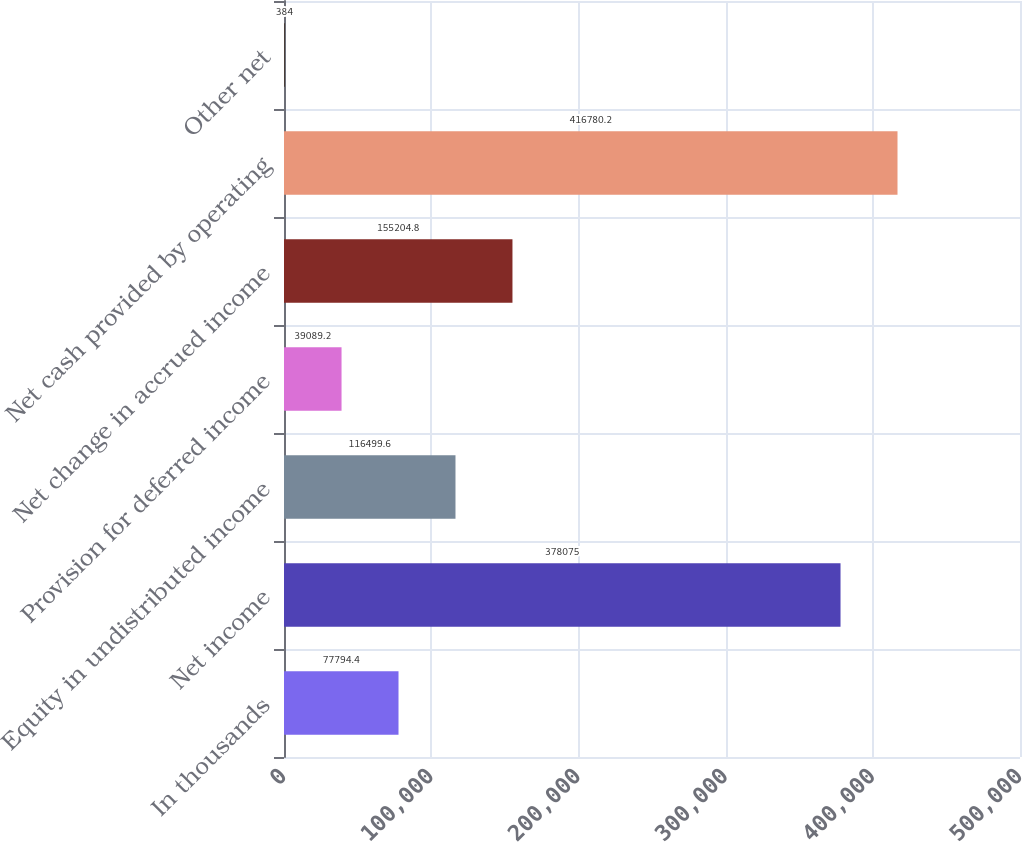<chart> <loc_0><loc_0><loc_500><loc_500><bar_chart><fcel>In thousands<fcel>Net income<fcel>Equity in undistributed income<fcel>Provision for deferred income<fcel>Net change in accrued income<fcel>Net cash provided by operating<fcel>Other net<nl><fcel>77794.4<fcel>378075<fcel>116500<fcel>39089.2<fcel>155205<fcel>416780<fcel>384<nl></chart> 